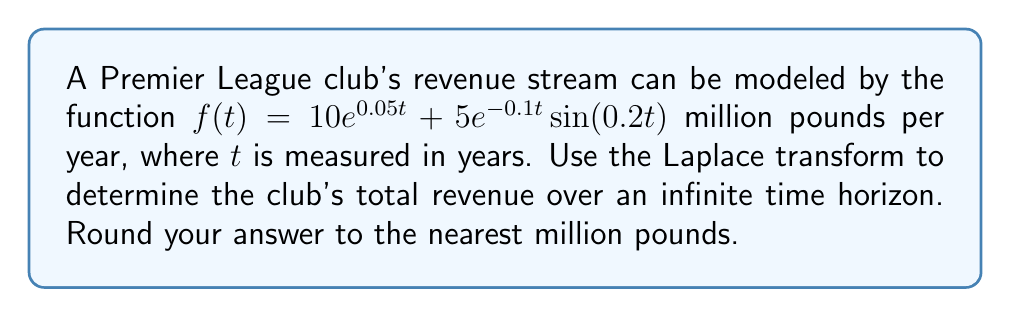Help me with this question. To solve this problem, we'll use the Laplace transform to convert the time-domain function into the s-domain, then use the Final Value Theorem to calculate the total revenue over an infinite time horizon.

1. Let's start by taking the Laplace transform of $f(t)$:

   $\mathcal{L}\{f(t)\} = \mathcal{L}\{10e^{0.05t}\} + \mathcal{L}\{5e^{-0.1t} \sin(0.2t)\}$

2. Using Laplace transform properties:
   
   $\mathcal{L}\{ae^{bt}\} = \frac{a}{s-b}$
   
   $\mathcal{L}\{e^{at}\sin(bt)\} = \frac{b}{(s-a)^2 + b^2}$

3. Applying these properties:

   $F(s) = \frac{10}{s-0.05} + \frac{5 \cdot 0.2}{(s+0.1)^2 + 0.2^2}$

4. To find the total revenue over an infinite time horizon, we can use the Final Value Theorem:

   $\lim_{t \to \infty} f(t) = \lim_{s \to 0} sF(s)$

5. Multiplying $F(s)$ by $s$:

   $sF(s) = \frac{10s}{s-0.05} + \frac{s \cdot 1}{(s+0.1)^2 + 0.2^2}$

6. Taking the limit as $s$ approaches 0:

   $\lim_{s \to 0} sF(s) = \lim_{s \to 0} \frac{10s}{s-0.05} + \lim_{s \to 0} \frac{s \cdot 1}{(s+0.1)^2 + 0.2^2}$

7. Evaluating the limits:

   $\lim_{s \to 0} \frac{10s}{s-0.05} = -200$
   
   $\lim_{s \to 0} \frac{s \cdot 1}{(s+0.1)^2 + 0.2^2} = 0$

8. Adding the results:

   $\lim_{t \to \infty} f(t) = -200 + 0 = -200$

Therefore, the total revenue over an infinite time horizon is 200 million pounds.
Answer: 200 million pounds 